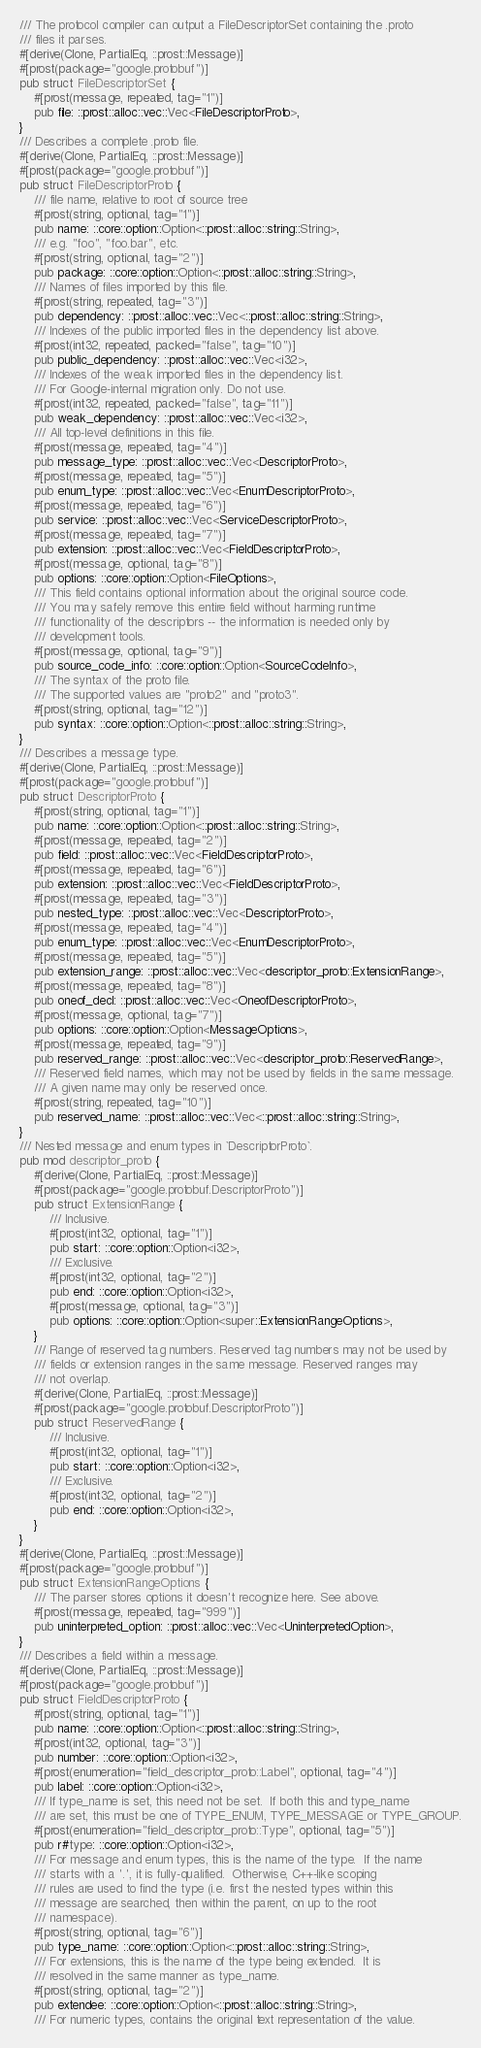<code> <loc_0><loc_0><loc_500><loc_500><_Rust_>/// The protocol compiler can output a FileDescriptorSet containing the .proto
/// files it parses.
#[derive(Clone, PartialEq, ::prost::Message)]
#[prost(package="google.protobuf")]
pub struct FileDescriptorSet {
    #[prost(message, repeated, tag="1")]
    pub file: ::prost::alloc::vec::Vec<FileDescriptorProto>,
}
/// Describes a complete .proto file.
#[derive(Clone, PartialEq, ::prost::Message)]
#[prost(package="google.protobuf")]
pub struct FileDescriptorProto {
    /// file name, relative to root of source tree
    #[prost(string, optional, tag="1")]
    pub name: ::core::option::Option<::prost::alloc::string::String>,
    /// e.g. "foo", "foo.bar", etc.
    #[prost(string, optional, tag="2")]
    pub package: ::core::option::Option<::prost::alloc::string::String>,
    /// Names of files imported by this file.
    #[prost(string, repeated, tag="3")]
    pub dependency: ::prost::alloc::vec::Vec<::prost::alloc::string::String>,
    /// Indexes of the public imported files in the dependency list above.
    #[prost(int32, repeated, packed="false", tag="10")]
    pub public_dependency: ::prost::alloc::vec::Vec<i32>,
    /// Indexes of the weak imported files in the dependency list.
    /// For Google-internal migration only. Do not use.
    #[prost(int32, repeated, packed="false", tag="11")]
    pub weak_dependency: ::prost::alloc::vec::Vec<i32>,
    /// All top-level definitions in this file.
    #[prost(message, repeated, tag="4")]
    pub message_type: ::prost::alloc::vec::Vec<DescriptorProto>,
    #[prost(message, repeated, tag="5")]
    pub enum_type: ::prost::alloc::vec::Vec<EnumDescriptorProto>,
    #[prost(message, repeated, tag="6")]
    pub service: ::prost::alloc::vec::Vec<ServiceDescriptorProto>,
    #[prost(message, repeated, tag="7")]
    pub extension: ::prost::alloc::vec::Vec<FieldDescriptorProto>,
    #[prost(message, optional, tag="8")]
    pub options: ::core::option::Option<FileOptions>,
    /// This field contains optional information about the original source code.
    /// You may safely remove this entire field without harming runtime
    /// functionality of the descriptors -- the information is needed only by
    /// development tools.
    #[prost(message, optional, tag="9")]
    pub source_code_info: ::core::option::Option<SourceCodeInfo>,
    /// The syntax of the proto file.
    /// The supported values are "proto2" and "proto3".
    #[prost(string, optional, tag="12")]
    pub syntax: ::core::option::Option<::prost::alloc::string::String>,
}
/// Describes a message type.
#[derive(Clone, PartialEq, ::prost::Message)]
#[prost(package="google.protobuf")]
pub struct DescriptorProto {
    #[prost(string, optional, tag="1")]
    pub name: ::core::option::Option<::prost::alloc::string::String>,
    #[prost(message, repeated, tag="2")]
    pub field: ::prost::alloc::vec::Vec<FieldDescriptorProto>,
    #[prost(message, repeated, tag="6")]
    pub extension: ::prost::alloc::vec::Vec<FieldDescriptorProto>,
    #[prost(message, repeated, tag="3")]
    pub nested_type: ::prost::alloc::vec::Vec<DescriptorProto>,
    #[prost(message, repeated, tag="4")]
    pub enum_type: ::prost::alloc::vec::Vec<EnumDescriptorProto>,
    #[prost(message, repeated, tag="5")]
    pub extension_range: ::prost::alloc::vec::Vec<descriptor_proto::ExtensionRange>,
    #[prost(message, repeated, tag="8")]
    pub oneof_decl: ::prost::alloc::vec::Vec<OneofDescriptorProto>,
    #[prost(message, optional, tag="7")]
    pub options: ::core::option::Option<MessageOptions>,
    #[prost(message, repeated, tag="9")]
    pub reserved_range: ::prost::alloc::vec::Vec<descriptor_proto::ReservedRange>,
    /// Reserved field names, which may not be used by fields in the same message.
    /// A given name may only be reserved once.
    #[prost(string, repeated, tag="10")]
    pub reserved_name: ::prost::alloc::vec::Vec<::prost::alloc::string::String>,
}
/// Nested message and enum types in `DescriptorProto`.
pub mod descriptor_proto {
    #[derive(Clone, PartialEq, ::prost::Message)]
    #[prost(package="google.protobuf.DescriptorProto")]
    pub struct ExtensionRange {
        /// Inclusive.
        #[prost(int32, optional, tag="1")]
        pub start: ::core::option::Option<i32>,
        /// Exclusive.
        #[prost(int32, optional, tag="2")]
        pub end: ::core::option::Option<i32>,
        #[prost(message, optional, tag="3")]
        pub options: ::core::option::Option<super::ExtensionRangeOptions>,
    }
    /// Range of reserved tag numbers. Reserved tag numbers may not be used by
    /// fields or extension ranges in the same message. Reserved ranges may
    /// not overlap.
    #[derive(Clone, PartialEq, ::prost::Message)]
    #[prost(package="google.protobuf.DescriptorProto")]
    pub struct ReservedRange {
        /// Inclusive.
        #[prost(int32, optional, tag="1")]
        pub start: ::core::option::Option<i32>,
        /// Exclusive.
        #[prost(int32, optional, tag="2")]
        pub end: ::core::option::Option<i32>,
    }
}
#[derive(Clone, PartialEq, ::prost::Message)]
#[prost(package="google.protobuf")]
pub struct ExtensionRangeOptions {
    /// The parser stores options it doesn't recognize here. See above.
    #[prost(message, repeated, tag="999")]
    pub uninterpreted_option: ::prost::alloc::vec::Vec<UninterpretedOption>,
}
/// Describes a field within a message.
#[derive(Clone, PartialEq, ::prost::Message)]
#[prost(package="google.protobuf")]
pub struct FieldDescriptorProto {
    #[prost(string, optional, tag="1")]
    pub name: ::core::option::Option<::prost::alloc::string::String>,
    #[prost(int32, optional, tag="3")]
    pub number: ::core::option::Option<i32>,
    #[prost(enumeration="field_descriptor_proto::Label", optional, tag="4")]
    pub label: ::core::option::Option<i32>,
    /// If type_name is set, this need not be set.  If both this and type_name
    /// are set, this must be one of TYPE_ENUM, TYPE_MESSAGE or TYPE_GROUP.
    #[prost(enumeration="field_descriptor_proto::Type", optional, tag="5")]
    pub r#type: ::core::option::Option<i32>,
    /// For message and enum types, this is the name of the type.  If the name
    /// starts with a '.', it is fully-qualified.  Otherwise, C++-like scoping
    /// rules are used to find the type (i.e. first the nested types within this
    /// message are searched, then within the parent, on up to the root
    /// namespace).
    #[prost(string, optional, tag="6")]
    pub type_name: ::core::option::Option<::prost::alloc::string::String>,
    /// For extensions, this is the name of the type being extended.  It is
    /// resolved in the same manner as type_name.
    #[prost(string, optional, tag="2")]
    pub extendee: ::core::option::Option<::prost::alloc::string::String>,
    /// For numeric types, contains the original text representation of the value.</code> 